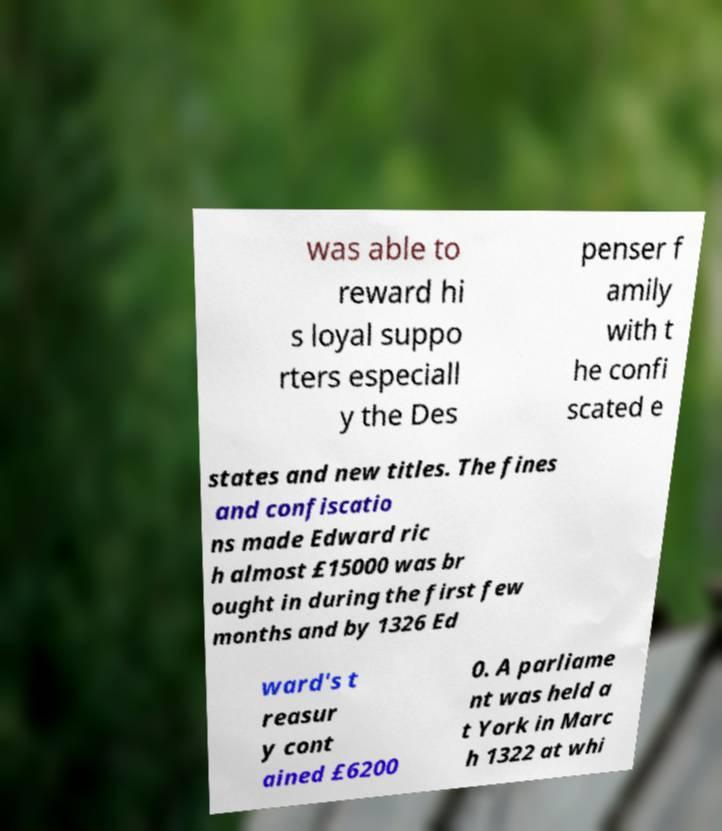For documentation purposes, I need the text within this image transcribed. Could you provide that? was able to reward hi s loyal suppo rters especiall y the Des penser f amily with t he confi scated e states and new titles. The fines and confiscatio ns made Edward ric h almost £15000 was br ought in during the first few months and by 1326 Ed ward's t reasur y cont ained £6200 0. A parliame nt was held a t York in Marc h 1322 at whi 